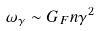Convert formula to latex. <formula><loc_0><loc_0><loc_500><loc_500>\omega _ { \gamma } \sim G _ { F } n \gamma ^ { 2 }</formula> 